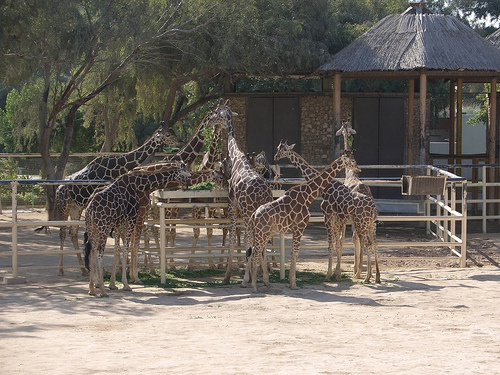Describe the objects in this image and their specific colors. I can see giraffe in black and gray tones, giraffe in black, gray, maroon, and darkgray tones, giraffe in black and gray tones, giraffe in black, gray, and darkgray tones, and giraffe in black and gray tones in this image. 